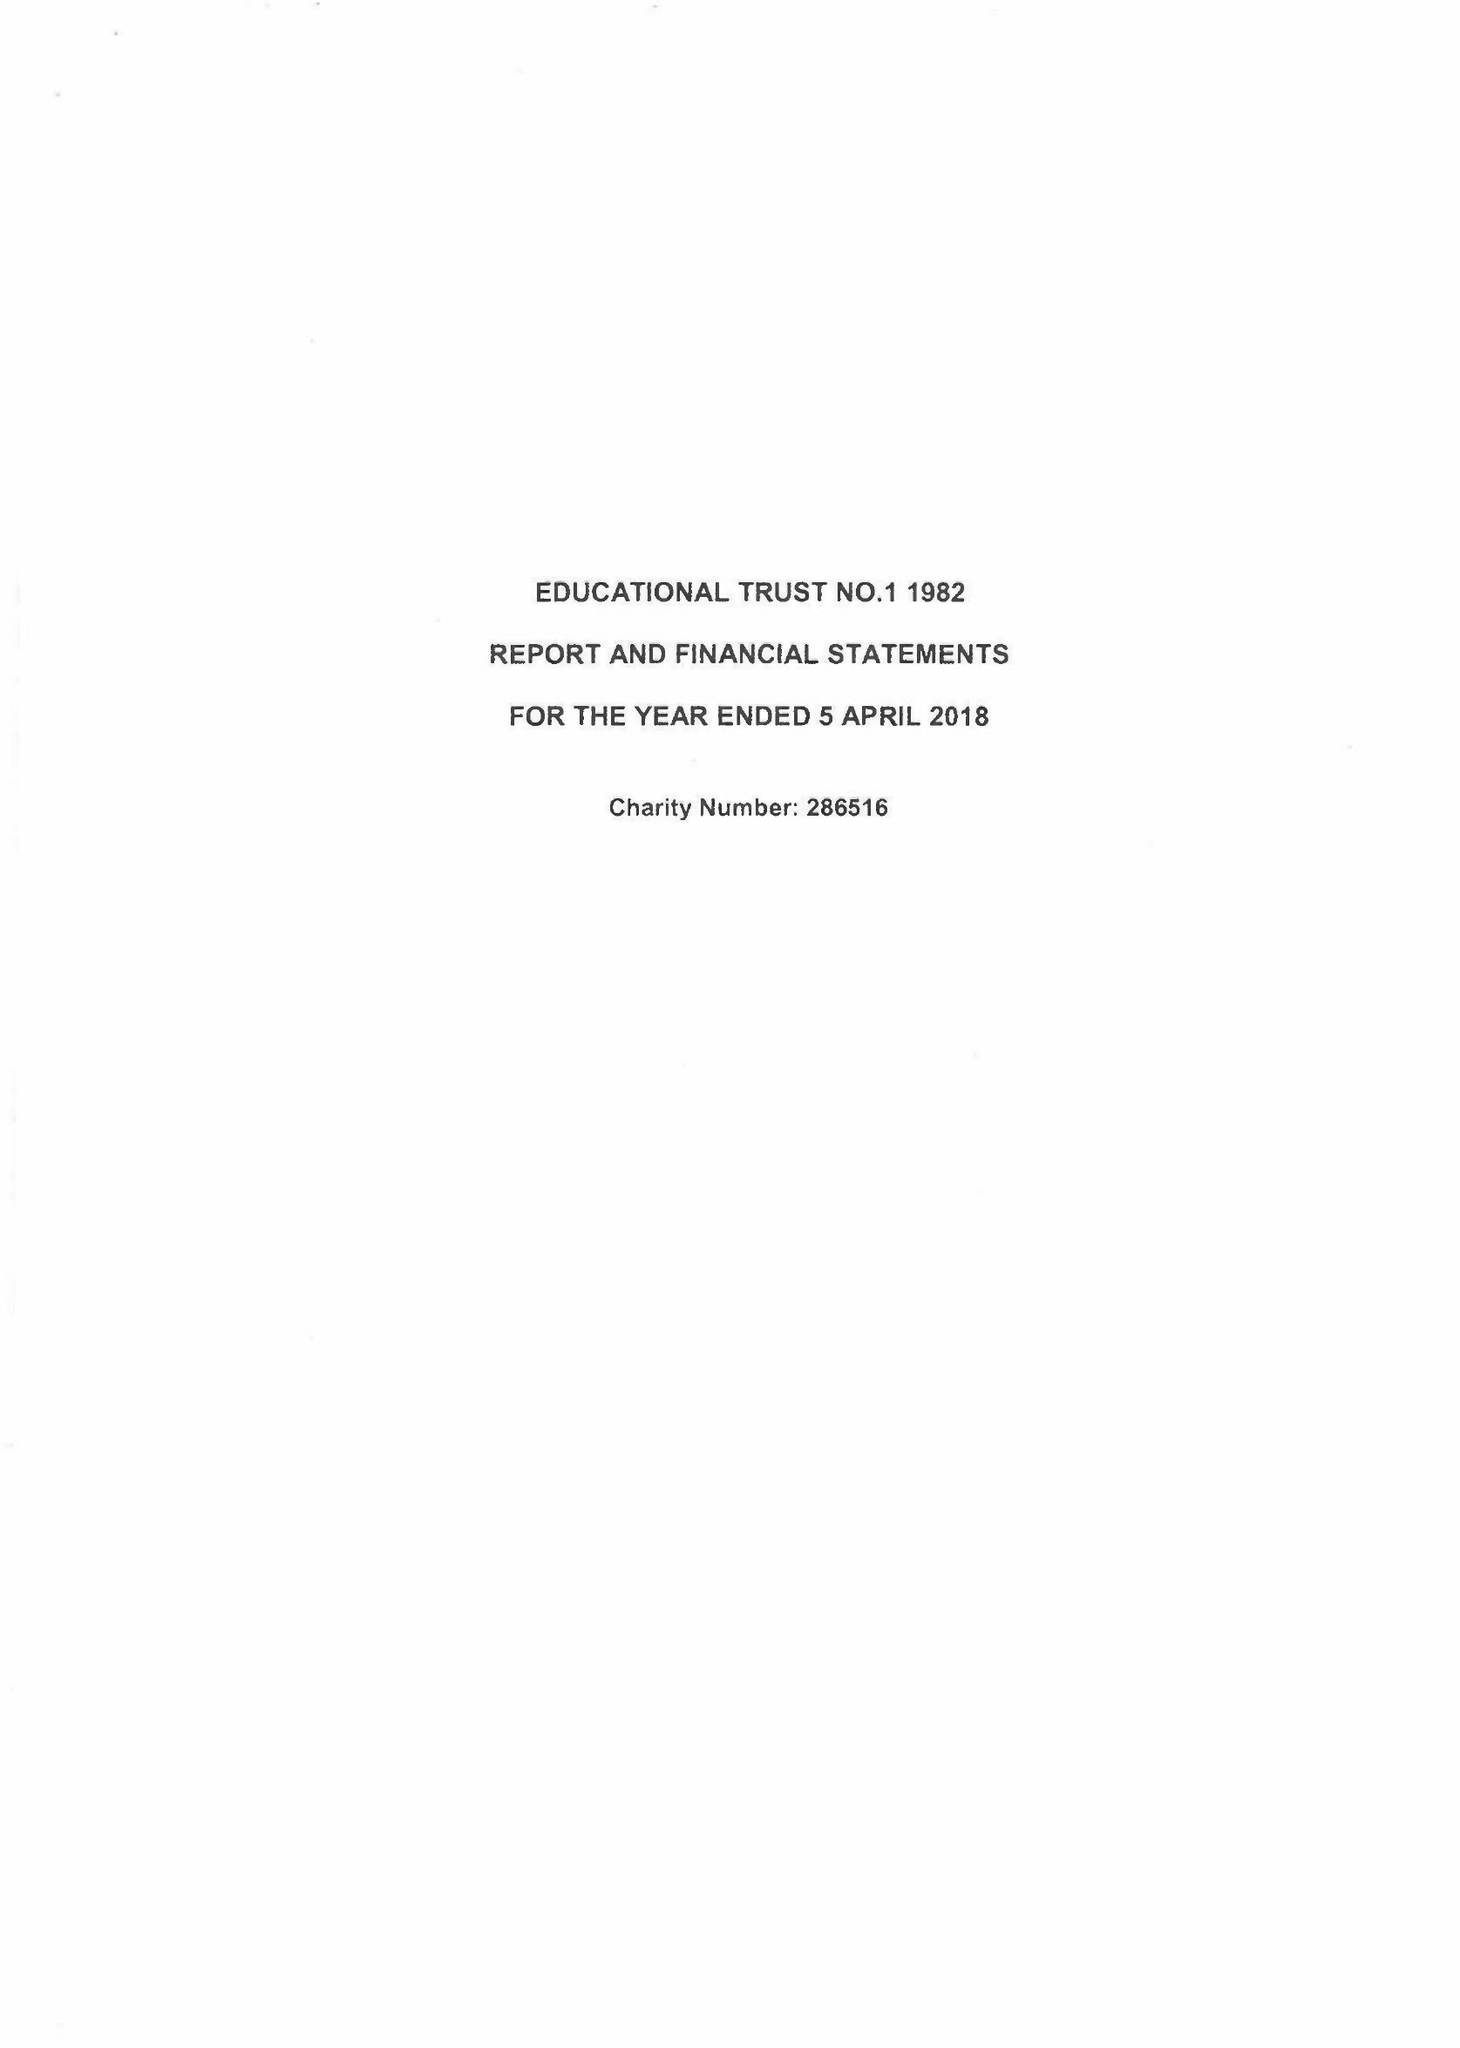What is the value for the income_annually_in_british_pounds?
Answer the question using a single word or phrase. 86964.00 